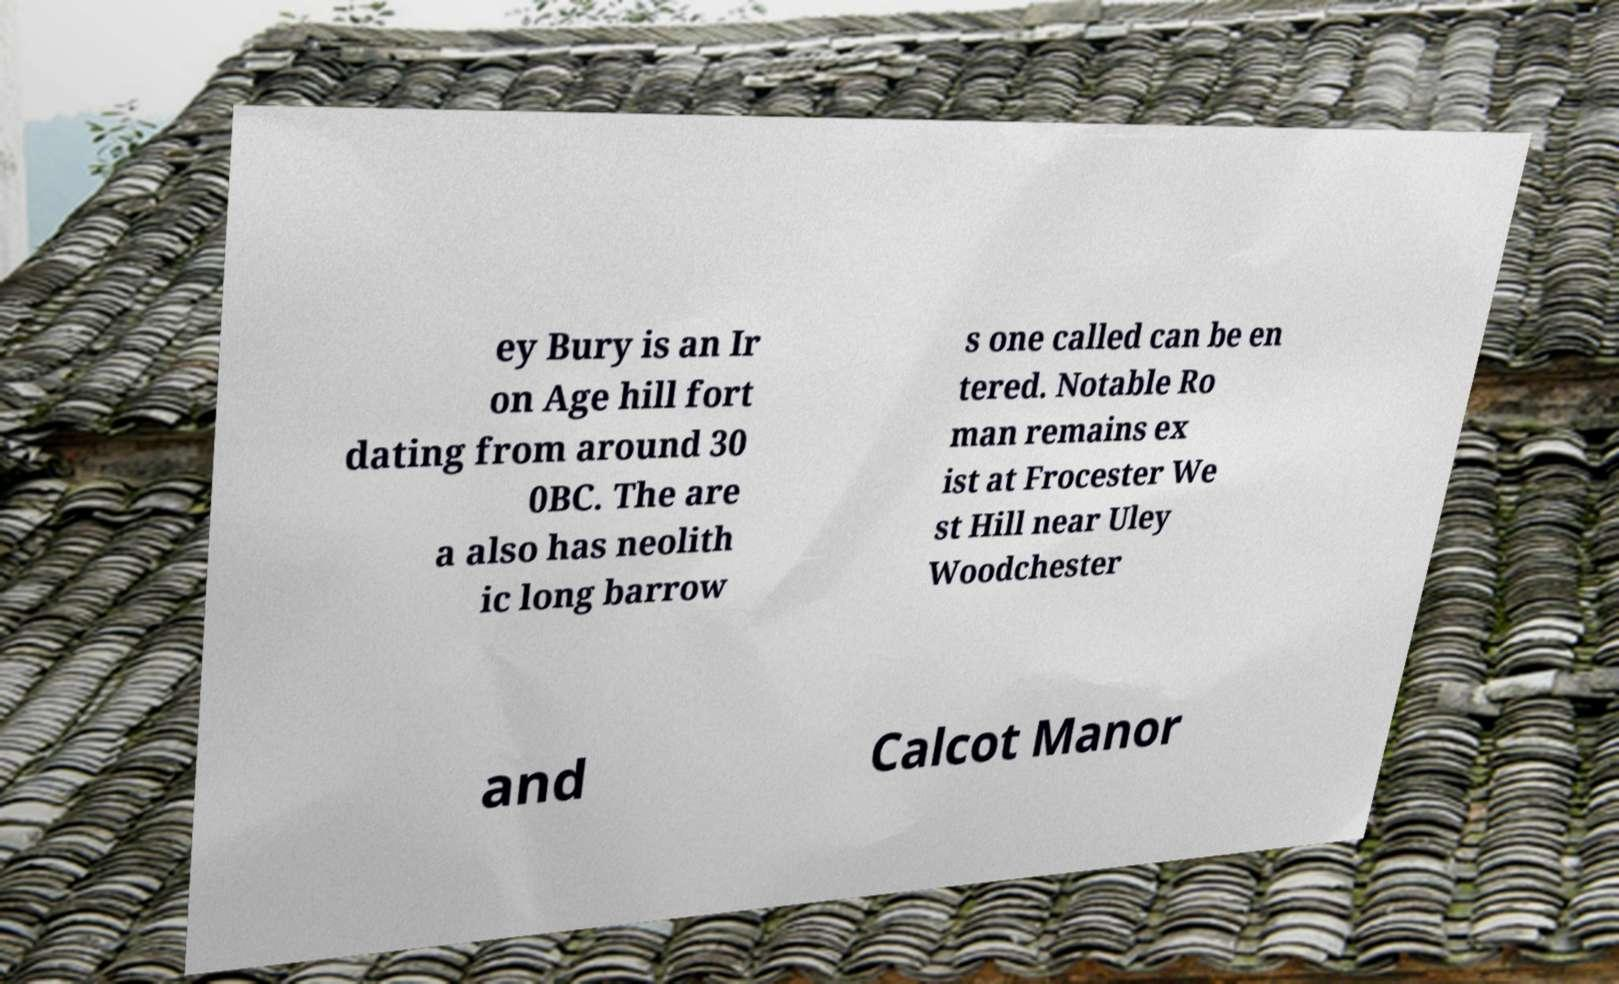Please identify and transcribe the text found in this image. ey Bury is an Ir on Age hill fort dating from around 30 0BC. The are a also has neolith ic long barrow s one called can be en tered. Notable Ro man remains ex ist at Frocester We st Hill near Uley Woodchester and Calcot Manor 